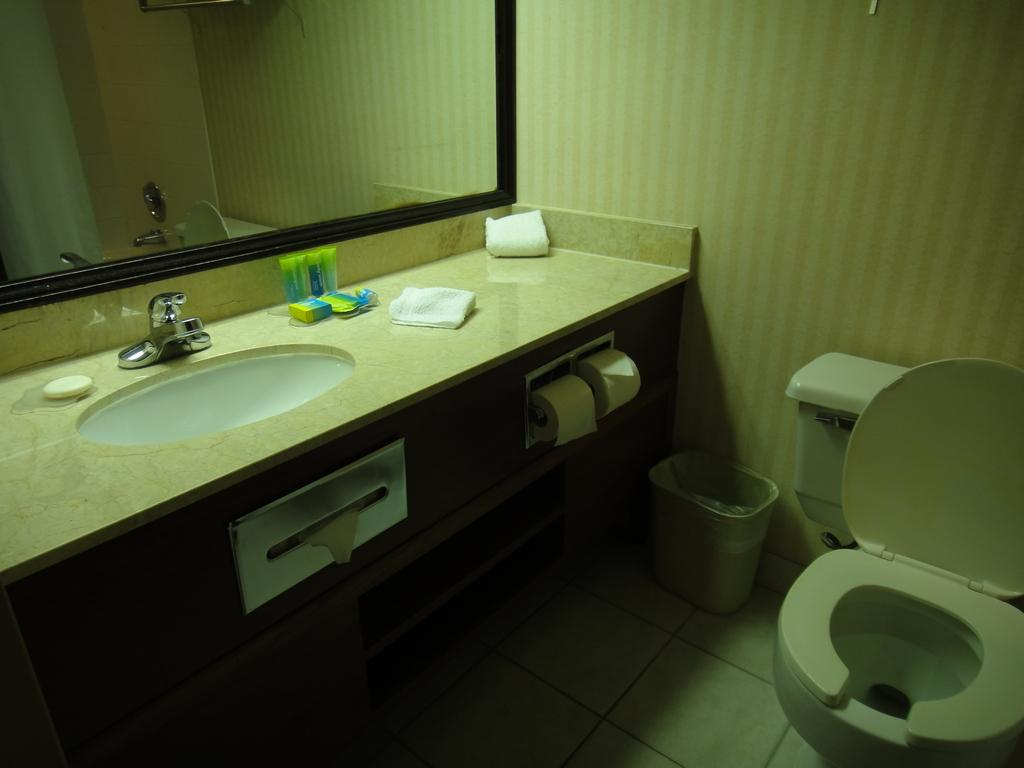What type of room is depicted in the image? The image depicts a bathroom. What is one of the main fixtures in a bathroom? There is a toilet in the bathroom. What is used for personal hygiene and grooming in the bathroom? There is a mirror and a sink in the bathroom. How is water supplied to the sink in the bathroom? There is a tap in the bathroom for supplying water. What is used for cleaning hands in the bathroom? There is soap in the bathroom. What is used for wiping after using the toilet in the bathroom? There is toilet paper in the bathroom. What is used for disposing of waste in the bathroom? There is a dustbin in the bathroom. What is used for drying hands or body after washing in the bathroom? There are towels in the bathroom. What type of representative paste is used for printing in the bathroom? There is no representative paste or printing activity present in the bathroom; the image only depicts a bathroom with its typical fixtures and items. 